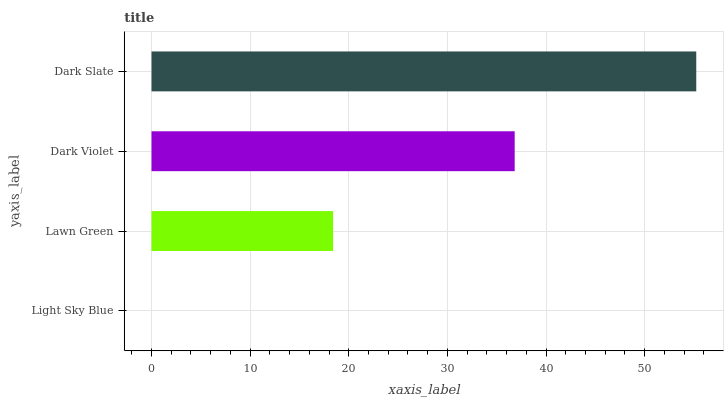Is Light Sky Blue the minimum?
Answer yes or no. Yes. Is Dark Slate the maximum?
Answer yes or no. Yes. Is Lawn Green the minimum?
Answer yes or no. No. Is Lawn Green the maximum?
Answer yes or no. No. Is Lawn Green greater than Light Sky Blue?
Answer yes or no. Yes. Is Light Sky Blue less than Lawn Green?
Answer yes or no. Yes. Is Light Sky Blue greater than Lawn Green?
Answer yes or no. No. Is Lawn Green less than Light Sky Blue?
Answer yes or no. No. Is Dark Violet the high median?
Answer yes or no. Yes. Is Lawn Green the low median?
Answer yes or no. Yes. Is Dark Slate the high median?
Answer yes or no. No. Is Dark Violet the low median?
Answer yes or no. No. 